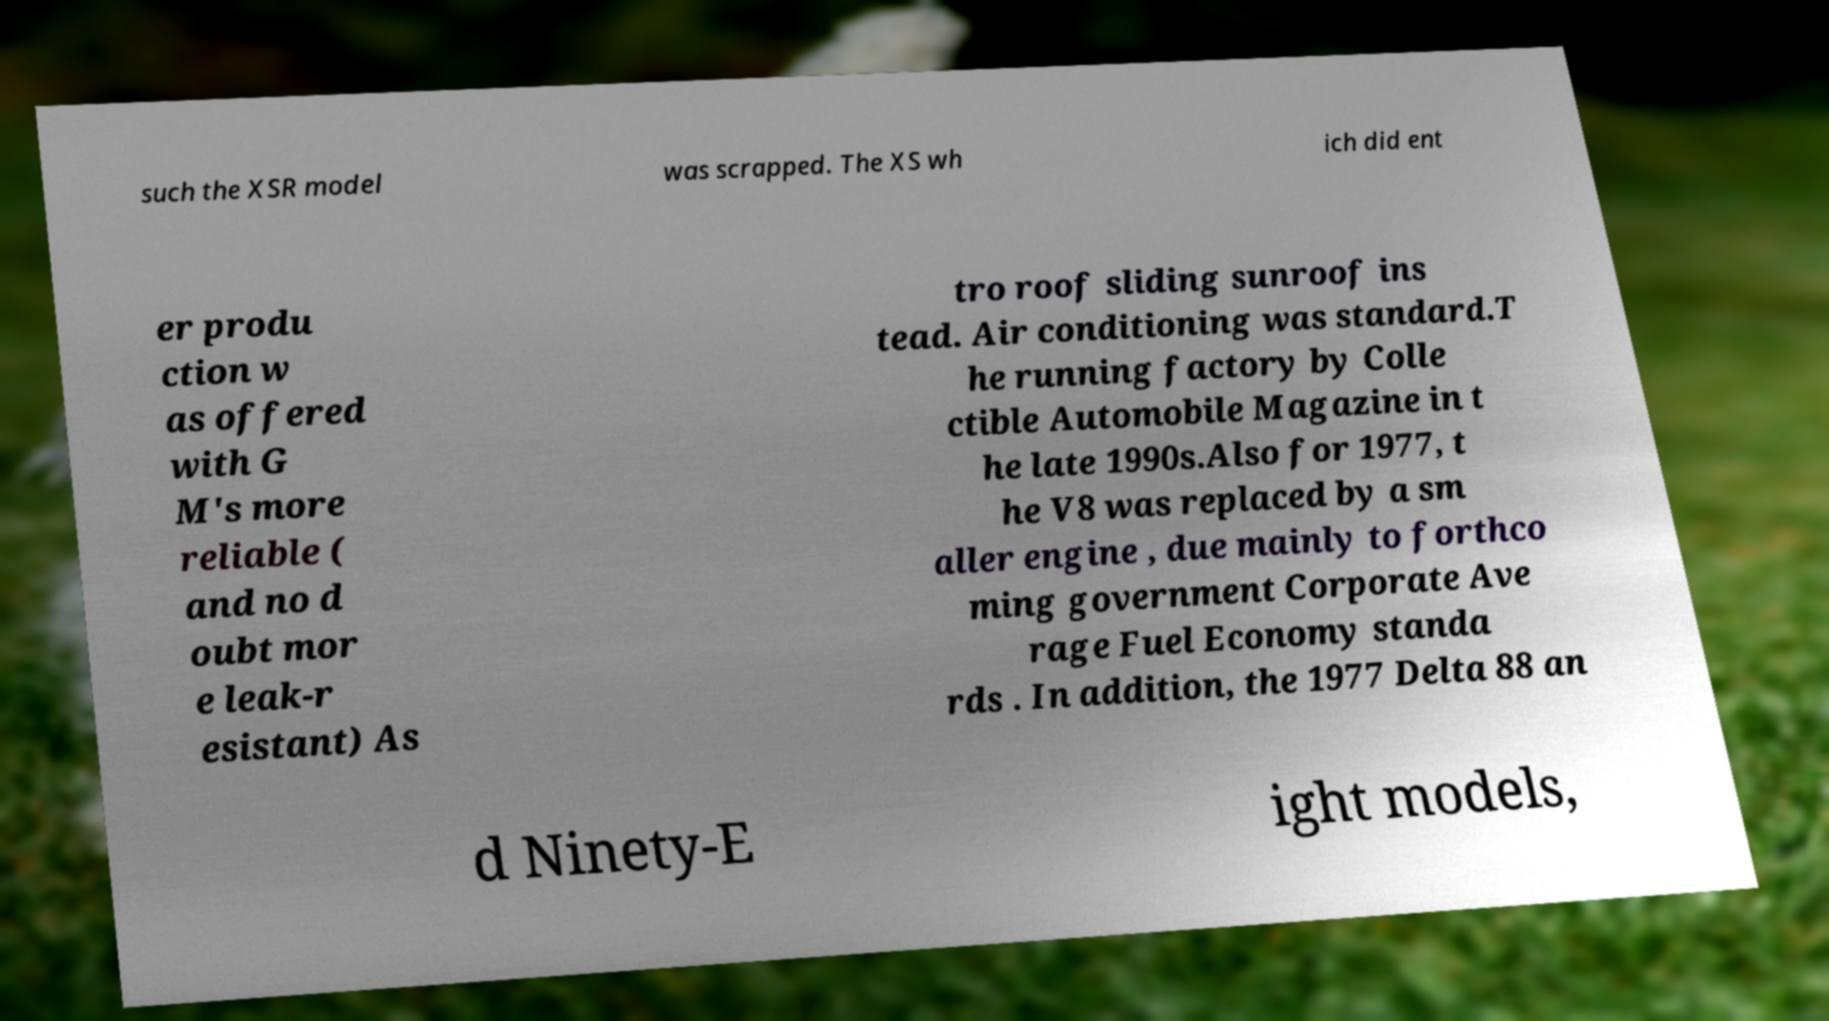Please identify and transcribe the text found in this image. such the XSR model was scrapped. The XS wh ich did ent er produ ction w as offered with G M's more reliable ( and no d oubt mor e leak-r esistant) As tro roof sliding sunroof ins tead. Air conditioning was standard.T he running factory by Colle ctible Automobile Magazine in t he late 1990s.Also for 1977, t he V8 was replaced by a sm aller engine , due mainly to forthco ming government Corporate Ave rage Fuel Economy standa rds . In addition, the 1977 Delta 88 an d Ninety-E ight models, 